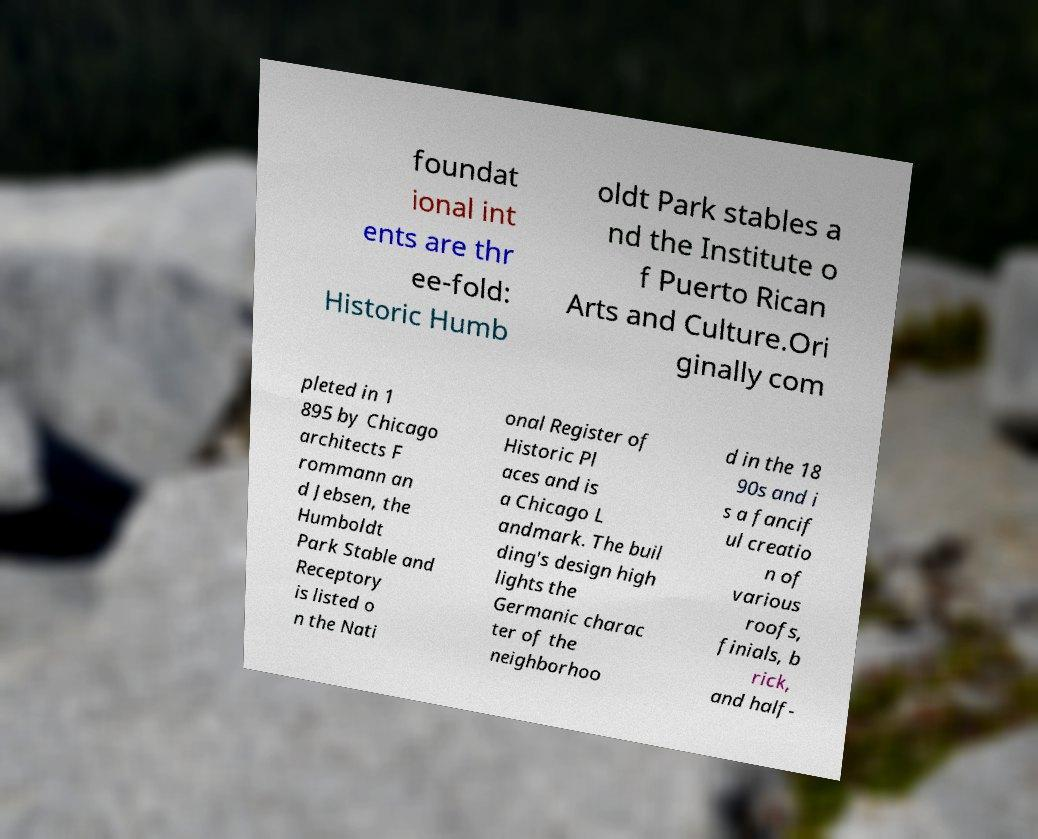Can you read and provide the text displayed in the image?This photo seems to have some interesting text. Can you extract and type it out for me? foundat ional int ents are thr ee-fold: Historic Humb oldt Park stables a nd the Institute o f Puerto Rican Arts and Culture.Ori ginally com pleted in 1 895 by Chicago architects F rommann an d Jebsen, the Humboldt Park Stable and Receptory is listed o n the Nati onal Register of Historic Pl aces and is a Chicago L andmark. The buil ding's design high lights the Germanic charac ter of the neighborhoo d in the 18 90s and i s a fancif ul creatio n of various roofs, finials, b rick, and half- 